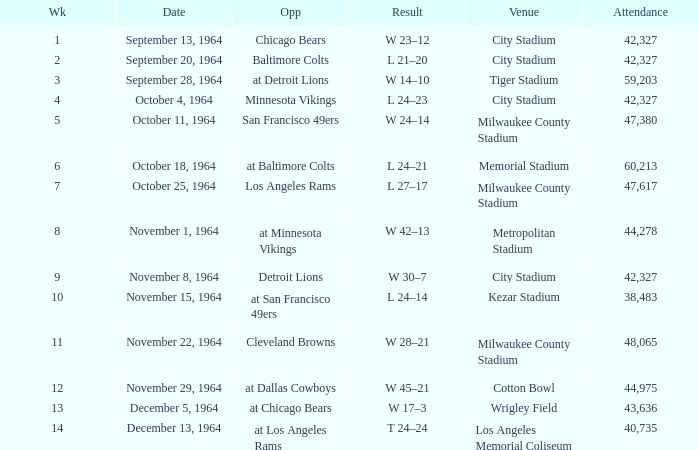What venue held that game with a result of l 24–14? Kezar Stadium. 